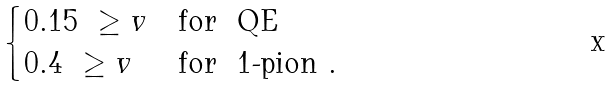Convert formula to latex. <formula><loc_0><loc_0><loc_500><loc_500>\begin{cases} 0 . 1 5 \ \geq v & \text {for \ QE} \\ 0 . 4 \ \geq v & \text {for \ 1-pion} \ . \end{cases}</formula> 